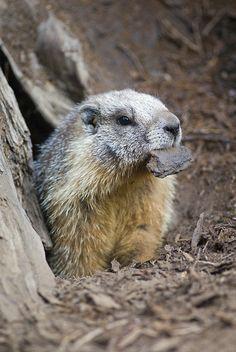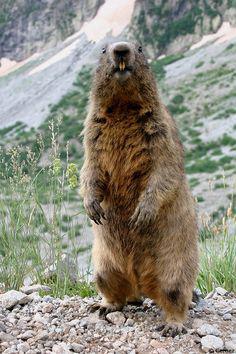The first image is the image on the left, the second image is the image on the right. Analyze the images presented: Is the assertion "At least one image features a rodent-type animal standing upright." valid? Answer yes or no. Yes. 